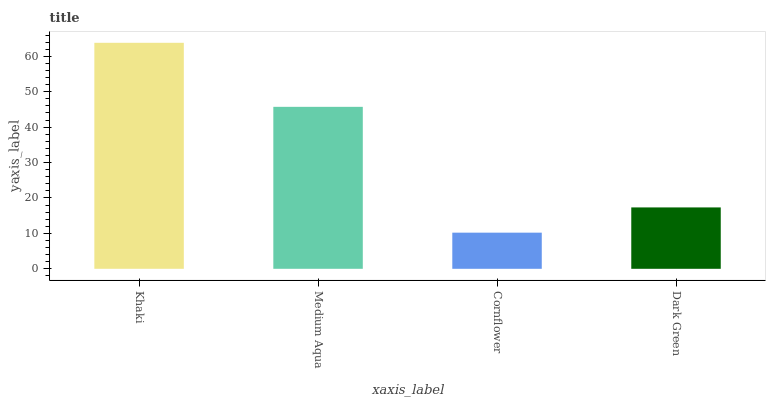Is Cornflower the minimum?
Answer yes or no. Yes. Is Khaki the maximum?
Answer yes or no. Yes. Is Medium Aqua the minimum?
Answer yes or no. No. Is Medium Aqua the maximum?
Answer yes or no. No. Is Khaki greater than Medium Aqua?
Answer yes or no. Yes. Is Medium Aqua less than Khaki?
Answer yes or no. Yes. Is Medium Aqua greater than Khaki?
Answer yes or no. No. Is Khaki less than Medium Aqua?
Answer yes or no. No. Is Medium Aqua the high median?
Answer yes or no. Yes. Is Dark Green the low median?
Answer yes or no. Yes. Is Dark Green the high median?
Answer yes or no. No. Is Cornflower the low median?
Answer yes or no. No. 